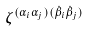<formula> <loc_0><loc_0><loc_500><loc_500>\zeta ^ { ( \alpha _ { i } \alpha _ { j } ) ( \dot { \beta } _ { i } \dot { \beta } _ { j } ) }</formula> 